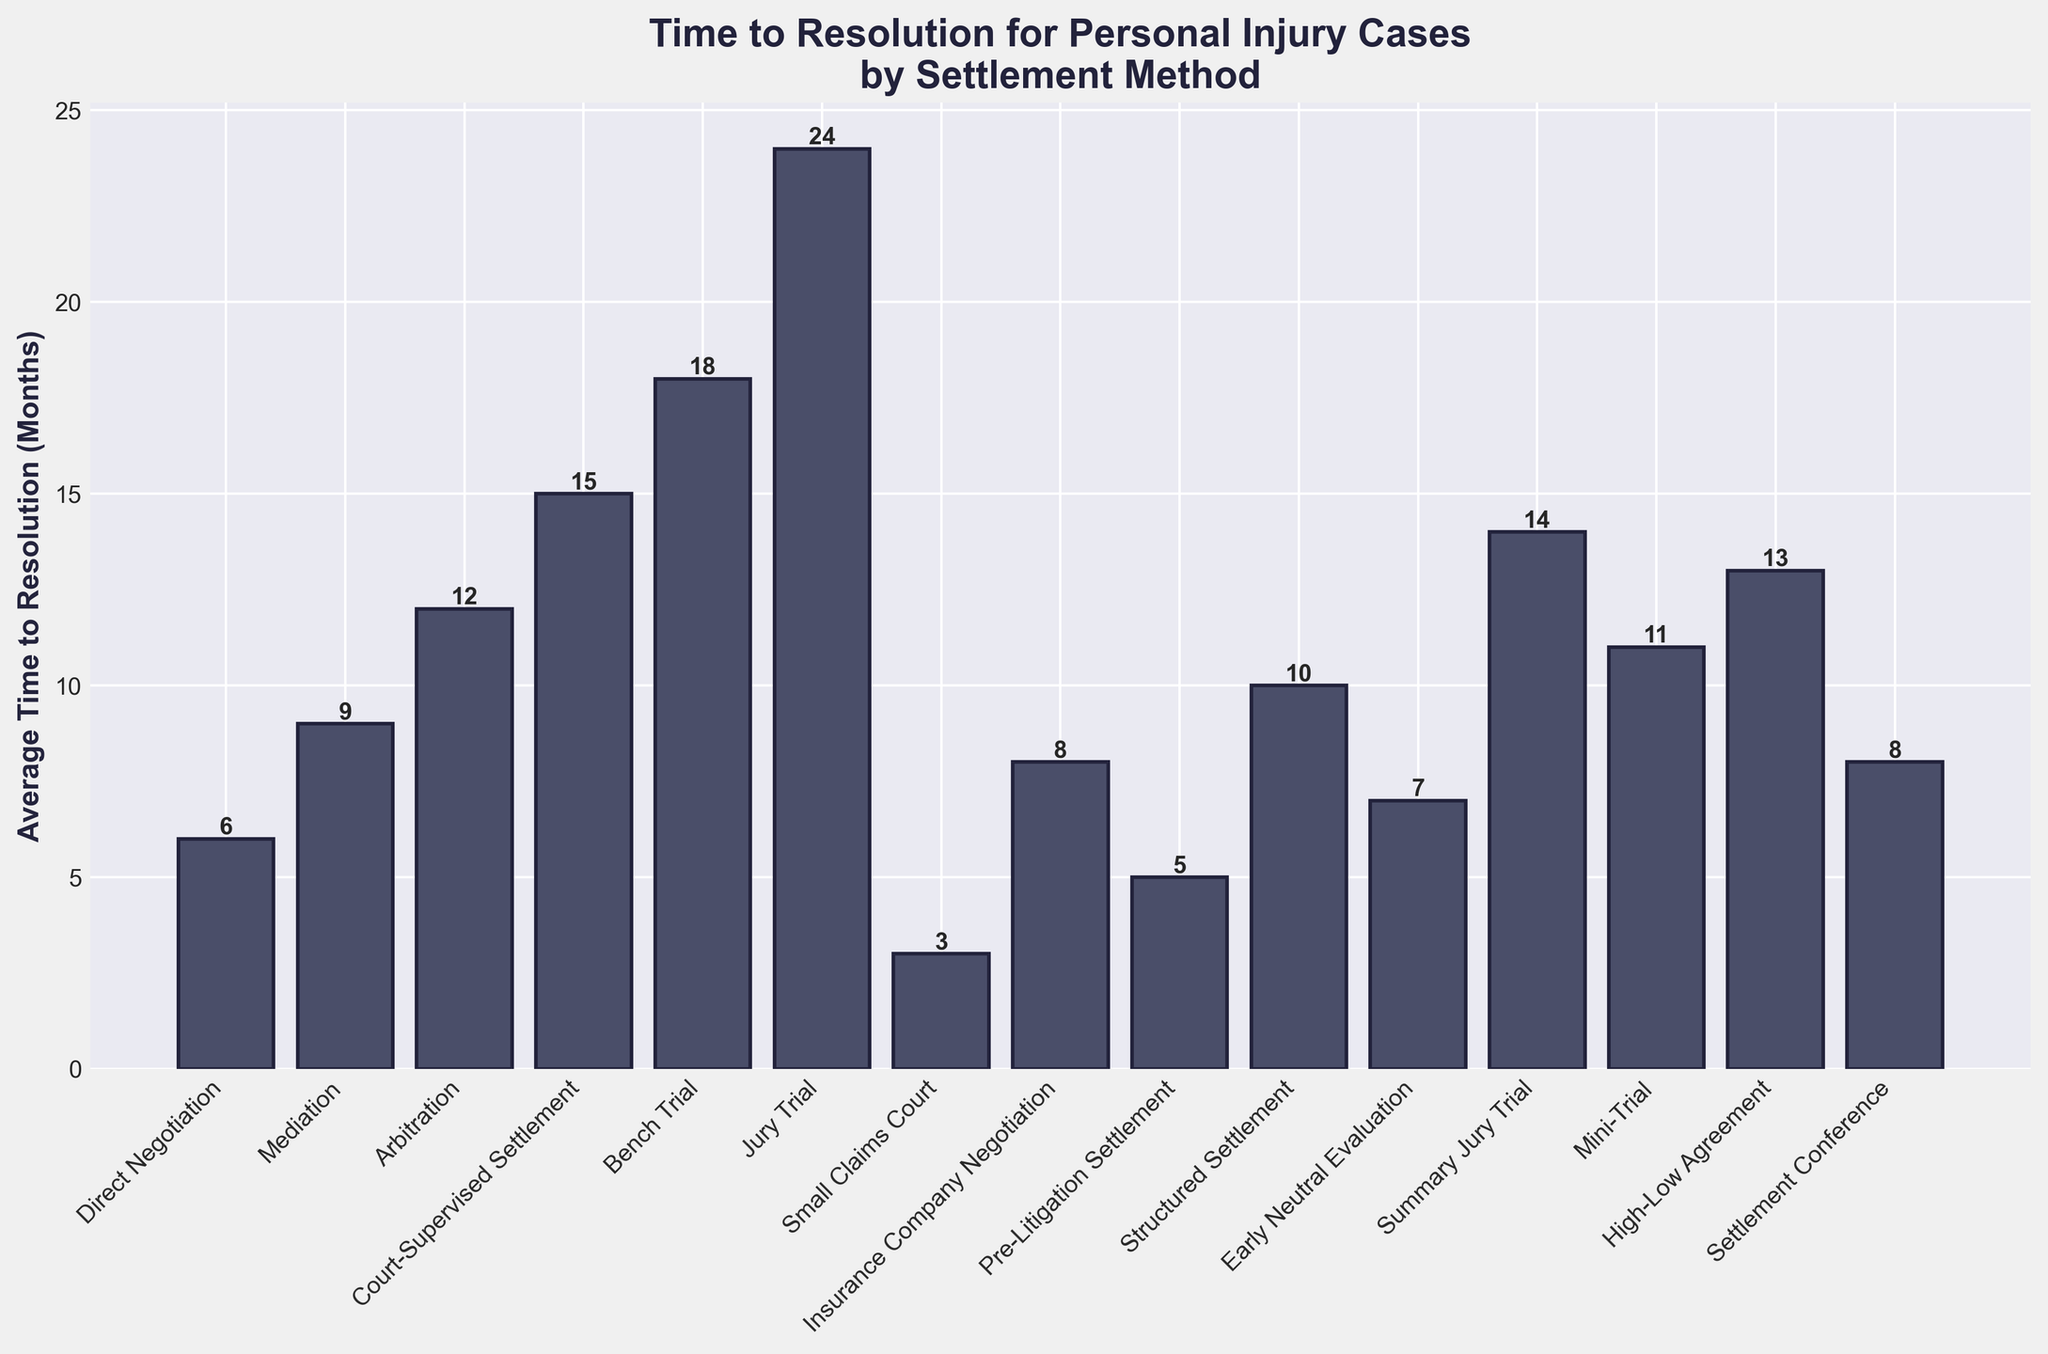Which settlement method takes the longest average time to resolve personal injury cases? The tallest bar on the plot represents the settlement method with the longest average time to resolution. The tallest bar corresponds to Jury Trial with an average time of 24 months.
Answer: Jury Trial Which methods resolve cases in less than a year on average? By examining the heights of the bars, we can see the methods corresponding to bars shorter than the 12-month mark. These methods are Direct Negotiation, Mediation, Small Claims Court, Insurance Company Negotiation, Pre-Litigation Settlement, Structured Settlement, Early Neutral Evaluation, and Settlement Conference.
Answer: Direct Negotiation, Mediation, Small Claims Court, Insurance Company Negotiation, Pre-Litigation Settlement, Structured Settlement, Early Neutral Evaluation, Settlement Conference How much longer does it take on average to resolve a case by Bench Trial compared to Mediation? From the plot, the average time for Bench Trial is 18 months and for Mediation is 9 months. Subtract the time for Mediation from the time for Bench Trial: 18 months - 9 months = 9 months.
Answer: 9 months Which settlement method has the shortest average time to resolution? The shortest bar on the plot represents the settlement method with the shortest average time to resolution. The shortest bar corresponds to Small Claims Court with an average time of 3 months.
Answer: Small Claims Court What is the average time to resolution for cases settled through High-Low Agreement? Look directly at the bar labeled High-Low Agreement. The height of the bar represents the average time, which is 13 months.
Answer: 13 months Compare the time difference between Arbitration and Mini-Trial. The heights of the bars for Arbitration and Mini-Trial are 12 months and 11 months, respectively. Subtract the time for Mini-Trial from the time for Arbitration: 12 months - 11 months = 1 month.
Answer: 1 month What visual attribute helps identify the most time-consuming settlement method? The visual attribute to look for is the height of the bars. The tallest bar indicates the most time-consuming settlement method, which in this case is for Jury Trial.
Answer: Height of the bar Arrange the following in descending order of time to resolution: Court-Supervised Settlement, Structured Settlement, Summary Jury Trial. Determine the height of each bar: Court-Supervised Settlement (15 months), Structured Settlement (10 months), Summary Jury Trial (14 months). Arrange in descending order: Summary Jury Trial (14 months), Court-Supervised Settlement (15 months), Structured Settlement (10 months).
Answer: Court-Supervised Settlement > Summary Jury Trial > Structured Settlement 